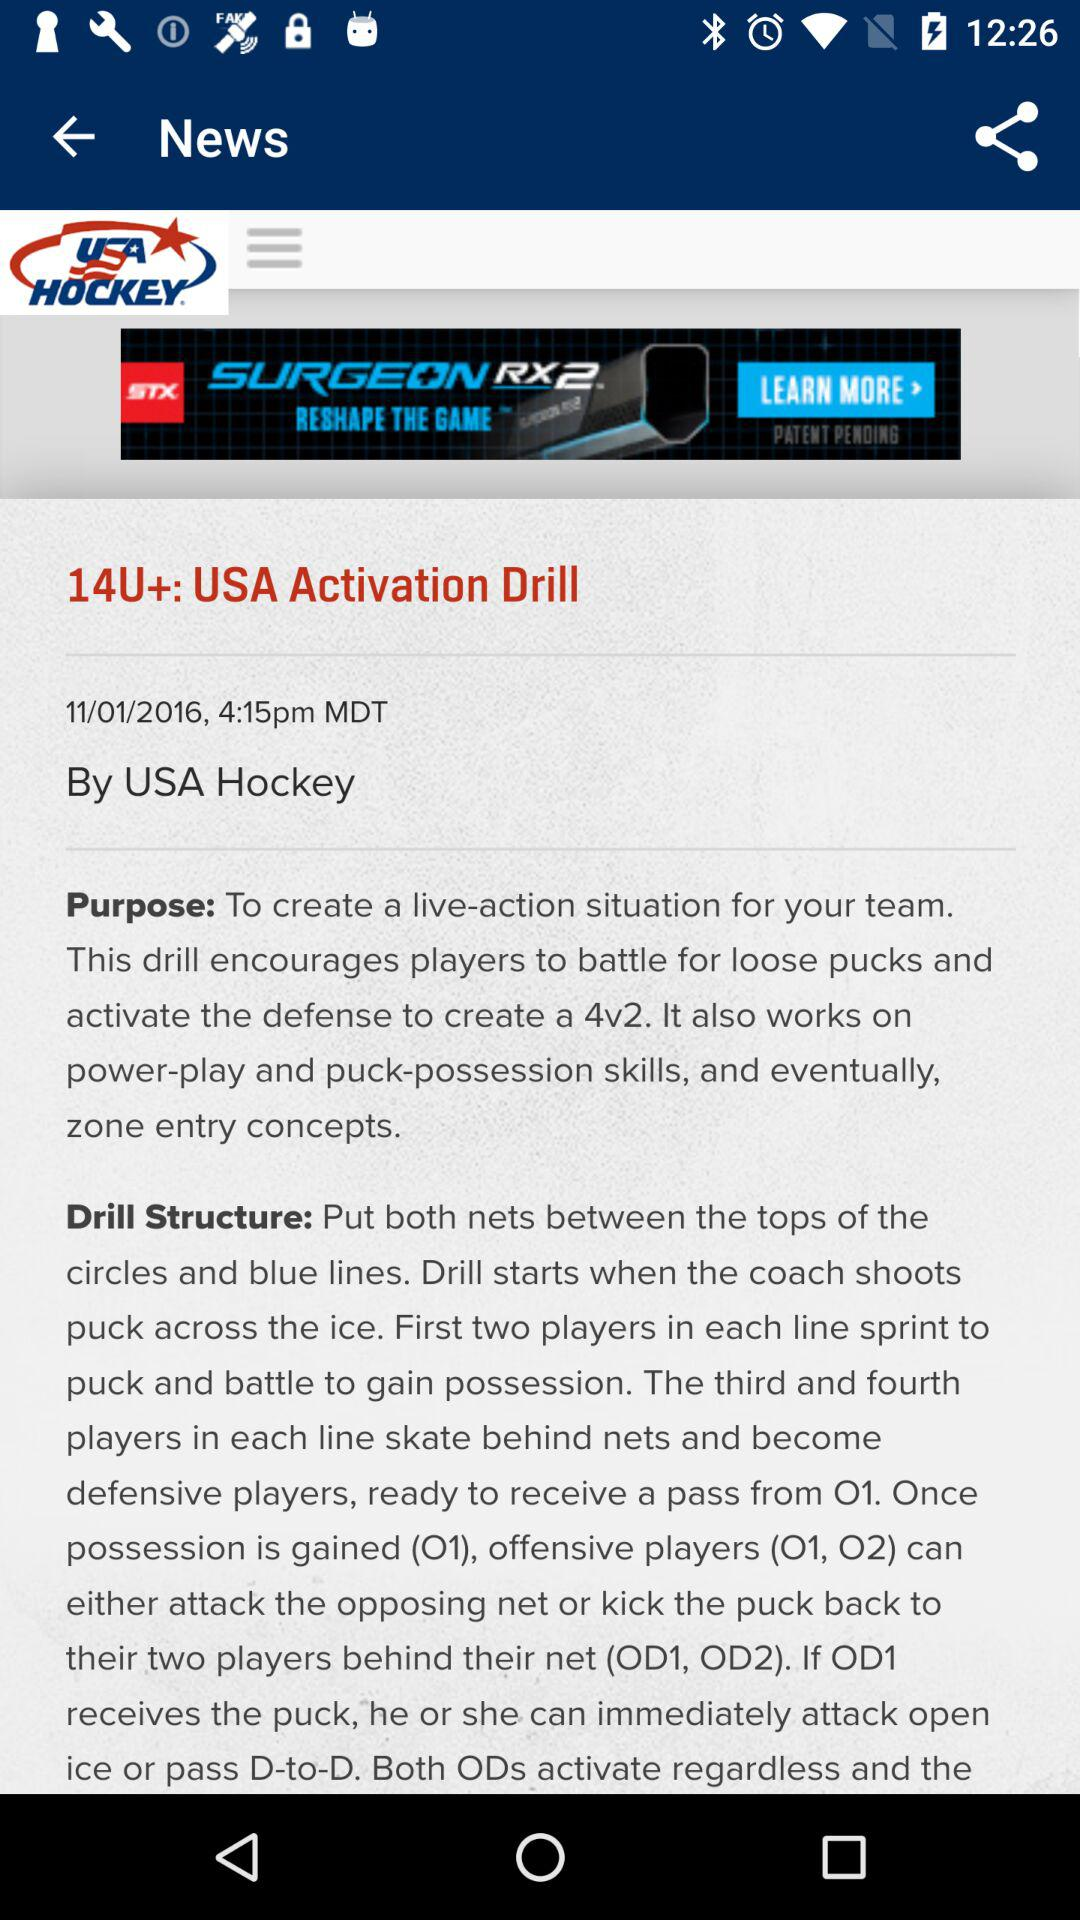What is the selected date? The selected date is 11/01/2016. 